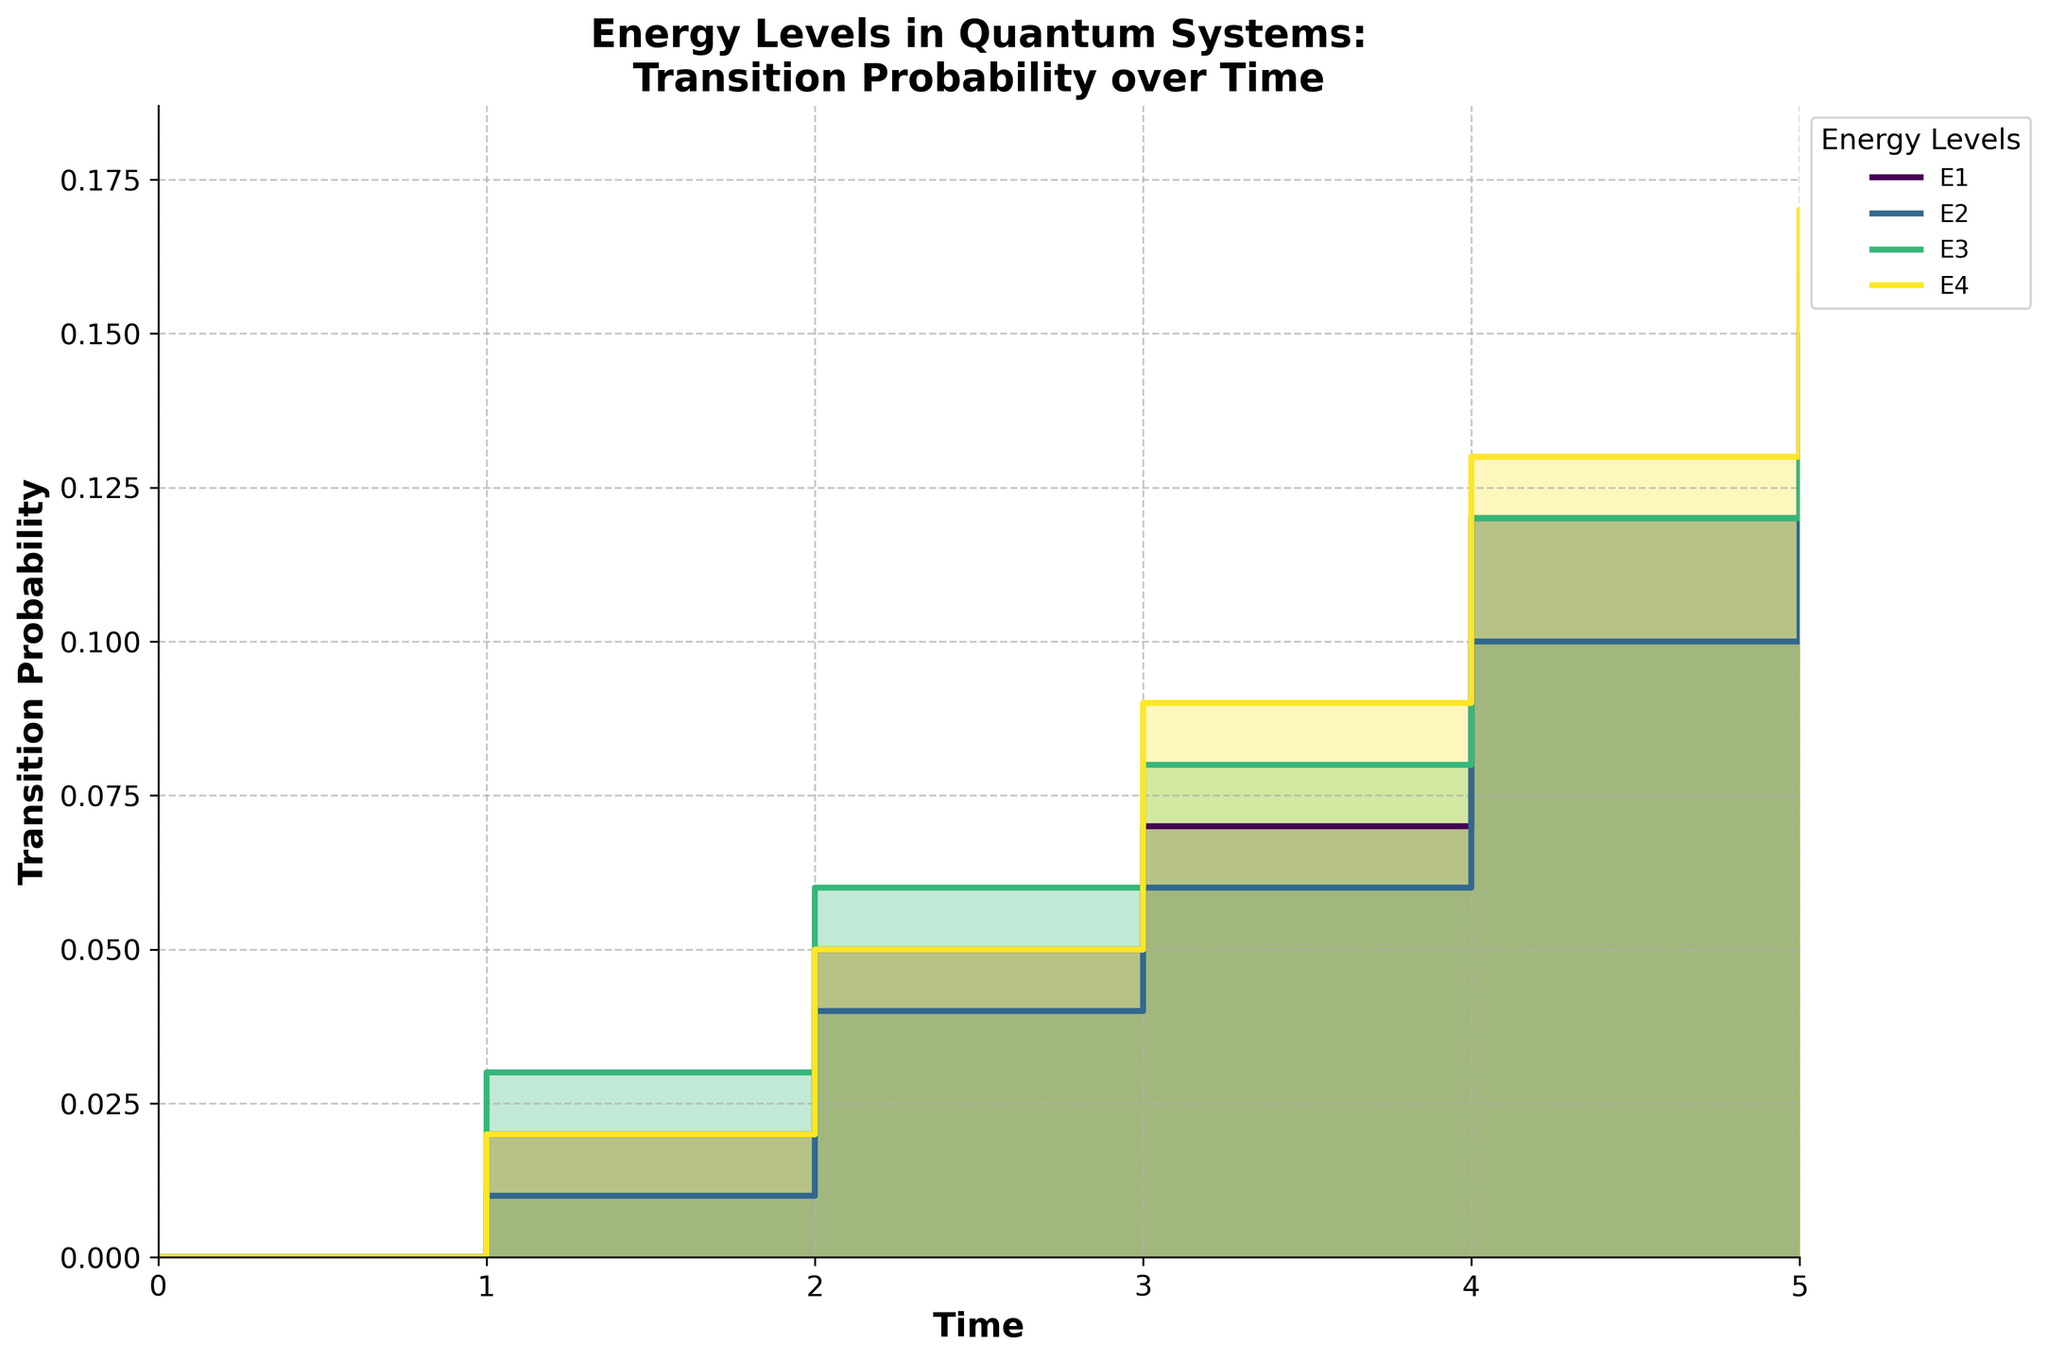What is the title of the figure? The title of the figure appears at the top and is usually in a larger font size to stand out. In this case, the title is "Energy Levels in Quantum Systems: Transition Probability over Time", indicating what the figure is about.
Answer: Energy Levels in Quantum Systems: Transition Probability over Time How many different energy levels are displayed in the figure? The legend of the figure lists all the different energy levels, each associated with a different color. There are four energy levels: E1, E2, E3, and E4.
Answer: 4 What is the transition probability for Energy Level E1 at Time = 3? The step area chart shows transition probabilities for different energy levels over time. By identifying the step corresponding to Energy Level E1 at Time = 3, we find the transition probability is 0.07.
Answer: 0.07 Compare the transition probabilities of Energy Level E2 and E3 at Time = 5. Which one is higher and by how much? By referring to the end points of the step areas for E2 and E3 at Time = 5, we see that the transition probability for E2 is 0.13 and for E3 is 0.16. Subtracting the two, the difference is 0.16 - 0.13 = 0.03.
Answer: E3 is higher by 0.03 What is the average transition probability for Energy Level E4 from Time = 0 to Time = 5? To determine the average, sum the transition probabilities of E4 from all time points (0, 0.02, 0.05, 0.09, 0.13, 0.17) and then divide by the number of time points (6). Average = (0 + 0.02 + 0.05 + 0.09 + 0.13 + 0.17) / 6 = 0.08.
Answer: 0.08 At which time point do E2 and E3 have the same transition probability, and what is this probability? By examining the plotted steps, we find that the transition probabilities of E2 and E3 intersect at Time = 3, with both having a transition probability of 0.06.
Answer: Time = 3, 0.06 Which energy level reaches the highest transition probability, and what is that value? The step area chart indicates the maximum y-axis value attained by each level. Energy Level E4 reaches the highest transition probability at 0.17 at Time = 5.
Answer: E4, 0.17 What overall trend can be observed in the transition probabilities of all energy levels over time? Observing the general pattern presented in the plot, all energy levels display an increasing trend in transition probabilities over time, indicating a rise in probability as time progresses.
Answer: Increasing trend 